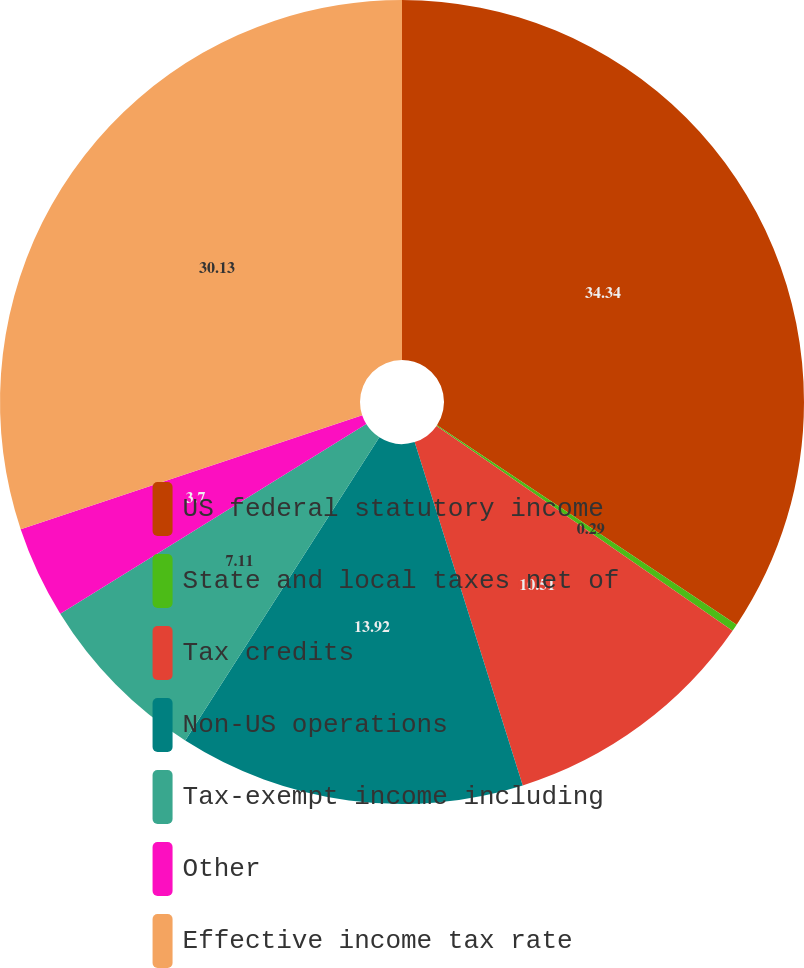Convert chart. <chart><loc_0><loc_0><loc_500><loc_500><pie_chart><fcel>US federal statutory income<fcel>State and local taxes net of<fcel>Tax credits<fcel>Non-US operations<fcel>Tax-exempt income including<fcel>Other<fcel>Effective income tax rate<nl><fcel>34.35%<fcel>0.29%<fcel>10.51%<fcel>13.92%<fcel>7.11%<fcel>3.7%<fcel>30.13%<nl></chart> 